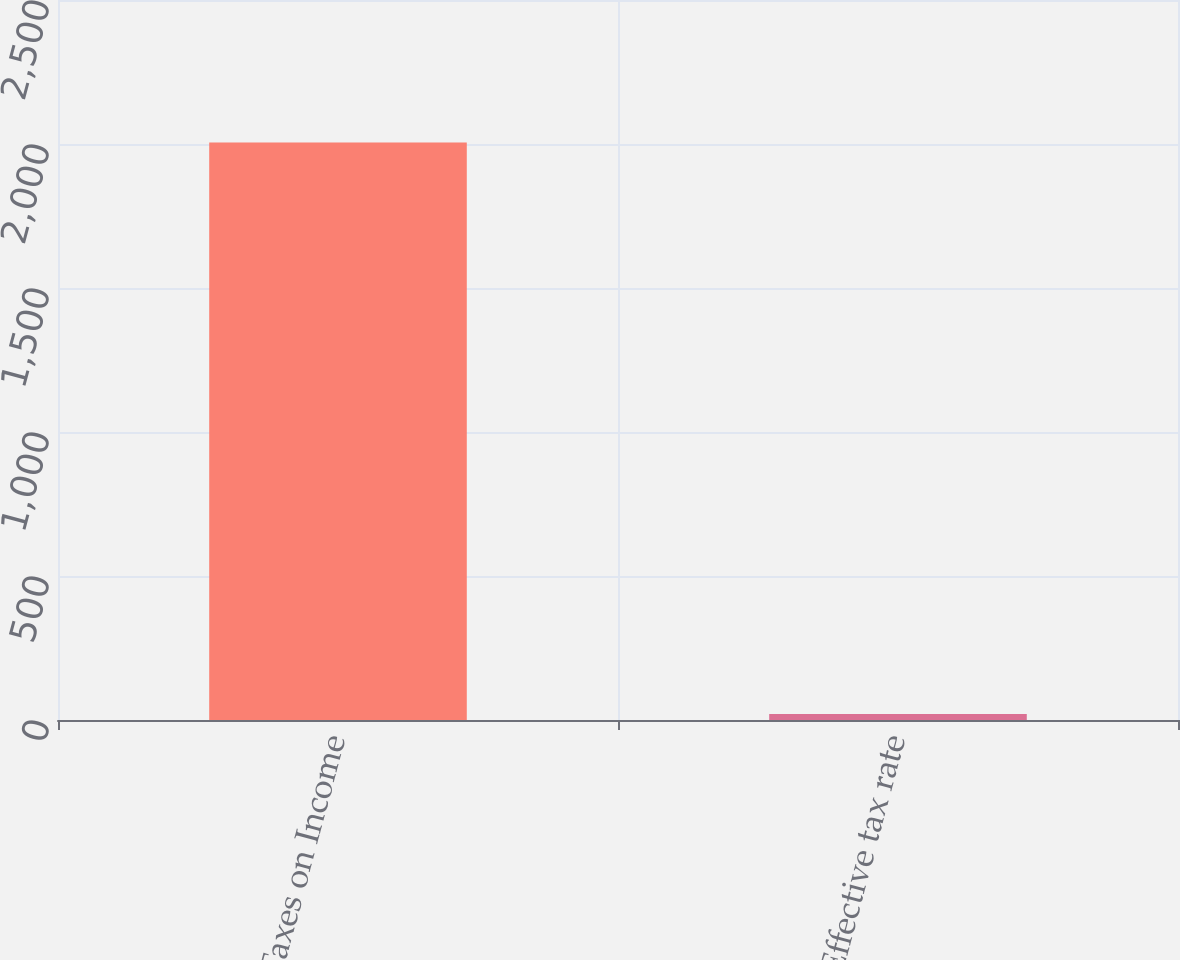Convert chart to OTSL. <chart><loc_0><loc_0><loc_500><loc_500><bar_chart><fcel>Taxes on Income<fcel>Effective tax rate<nl><fcel>2005<fcel>20.4<nl></chart> 